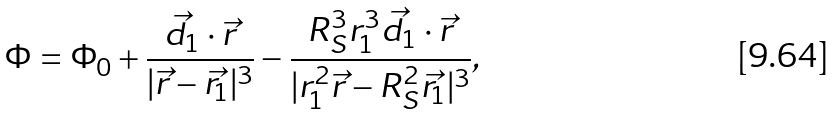<formula> <loc_0><loc_0><loc_500><loc_500>\Phi = \Phi _ { 0 } + \frac { \vec { d _ { 1 } } \cdot \vec { r } } { | \vec { r } - \vec { r _ { 1 } } | ^ { 3 } } - \frac { R _ { S } ^ { 3 } r _ { 1 } ^ { 3 } \vec { d _ { 1 } } \cdot \vec { r } } { | r _ { 1 } ^ { 2 } \vec { r } - R _ { S } ^ { 2 } \vec { r _ { 1 } } | ^ { 3 } } ,</formula> 